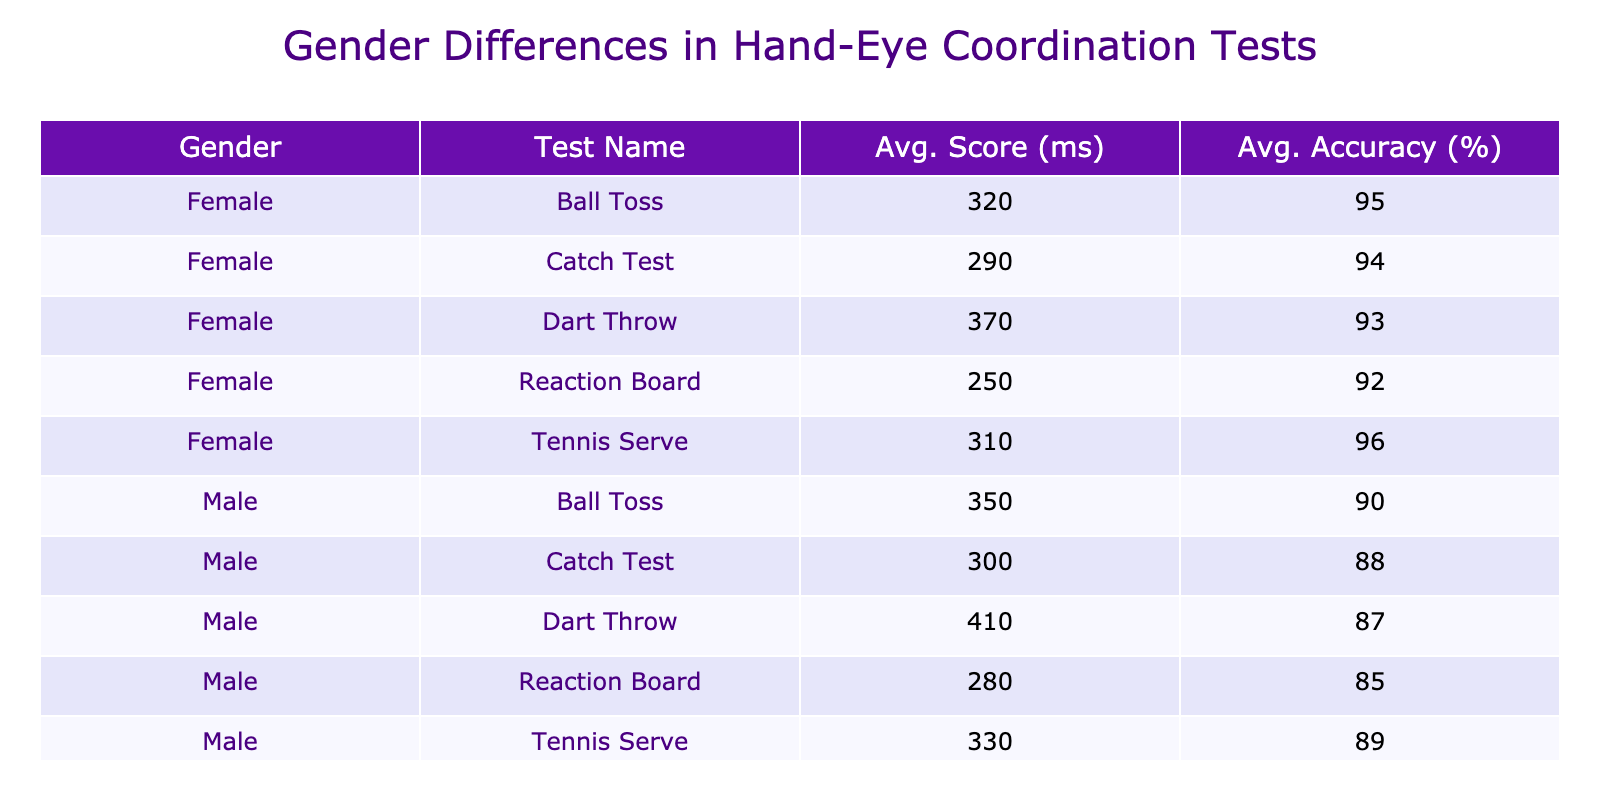What is the average score for the Dart Throw test for females? The score for females in the Dart Throw test is 370 ms. Since there's only one female participant, the average score is the same as the individual score.
Answer: 370 What is the average accuracy for the Ball Toss test for males? The accuracy for males in the Ball Toss test is 90%. Since there's only one male participant, the average accuracy is the same as the individual value.
Answer: 90% Which gender had a better average score in the Reaction Board test? The average score for males in the Reaction Board is 280 ms, while females scored an average of 250 ms. Since 250 is lower than 280, females performed better.
Answer: Females What is the average score difference between the Tennis Serve test for males and females? The average score for males in the Tennis Serve is 330 ms, and for females, it's 310 ms. The difference is calculated as 330 - 310 = 20 ms.
Answer: 20 ms Did any male achieve a higher average accuracy than any female in the Catch Test? The average accuracy for males in the Catch Test is 88%, while females scored 94%. Since 88% is less than 94%, the answer is no; no male performed better.
Answer: No What is the average score for all tests combined for the females? The average scores for females across all tests are: Ball Toss (320), Reaction Board (250), Dart Throw (370), Catch Test (290), and Tennis Serve (310). The total is 320 + 250 + 370 + 290 + 310 = 1540 ms, and there are 5 tests, so the average is 1540/5 = 308 ms.
Answer: 308 ms Was the average accuracy in the Dart Throw test higher for males compared to females? The average accuracy for males in the Dart Throw is 87%, while females scored 93%. Since 87% is lower than 93%, the answer is no.
Answer: No Which test had the highest average score among all participants? The highest average score is in the Dart Throw test with males averaging 410 ms and females averaging 370 ms. Thus, the highest overall average score is 410 ms from males.
Answer: 410 ms What is the overall average accuracy for male students across all tests? The accuracies for males are: Ball Toss (90%), Reaction Board (85%), Dart Throw (87%), Catch Test (88%), and Tennis Serve (89%). Therefore, the total is 90 + 85 + 87 + 88 + 89 = 439, and average is 439/5 = 87.8%.
Answer: 87.8% 